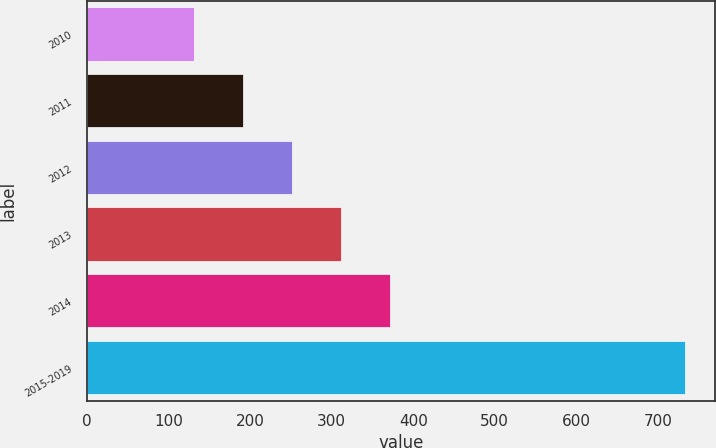Convert chart. <chart><loc_0><loc_0><loc_500><loc_500><bar_chart><fcel>2010<fcel>2011<fcel>2012<fcel>2013<fcel>2014<fcel>2015-2019<nl><fcel>131<fcel>191.2<fcel>251.4<fcel>311.6<fcel>371.8<fcel>733<nl></chart> 